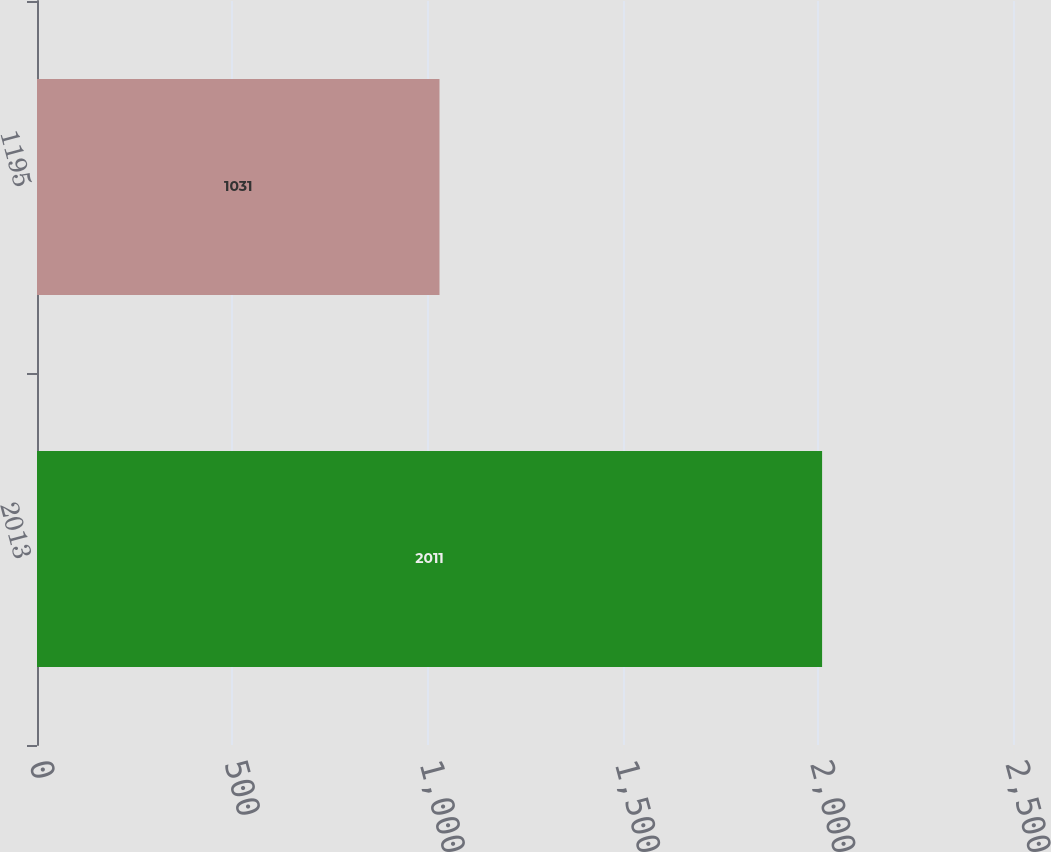Convert chart. <chart><loc_0><loc_0><loc_500><loc_500><bar_chart><fcel>2013<fcel>1195<nl><fcel>2011<fcel>1031<nl></chart> 